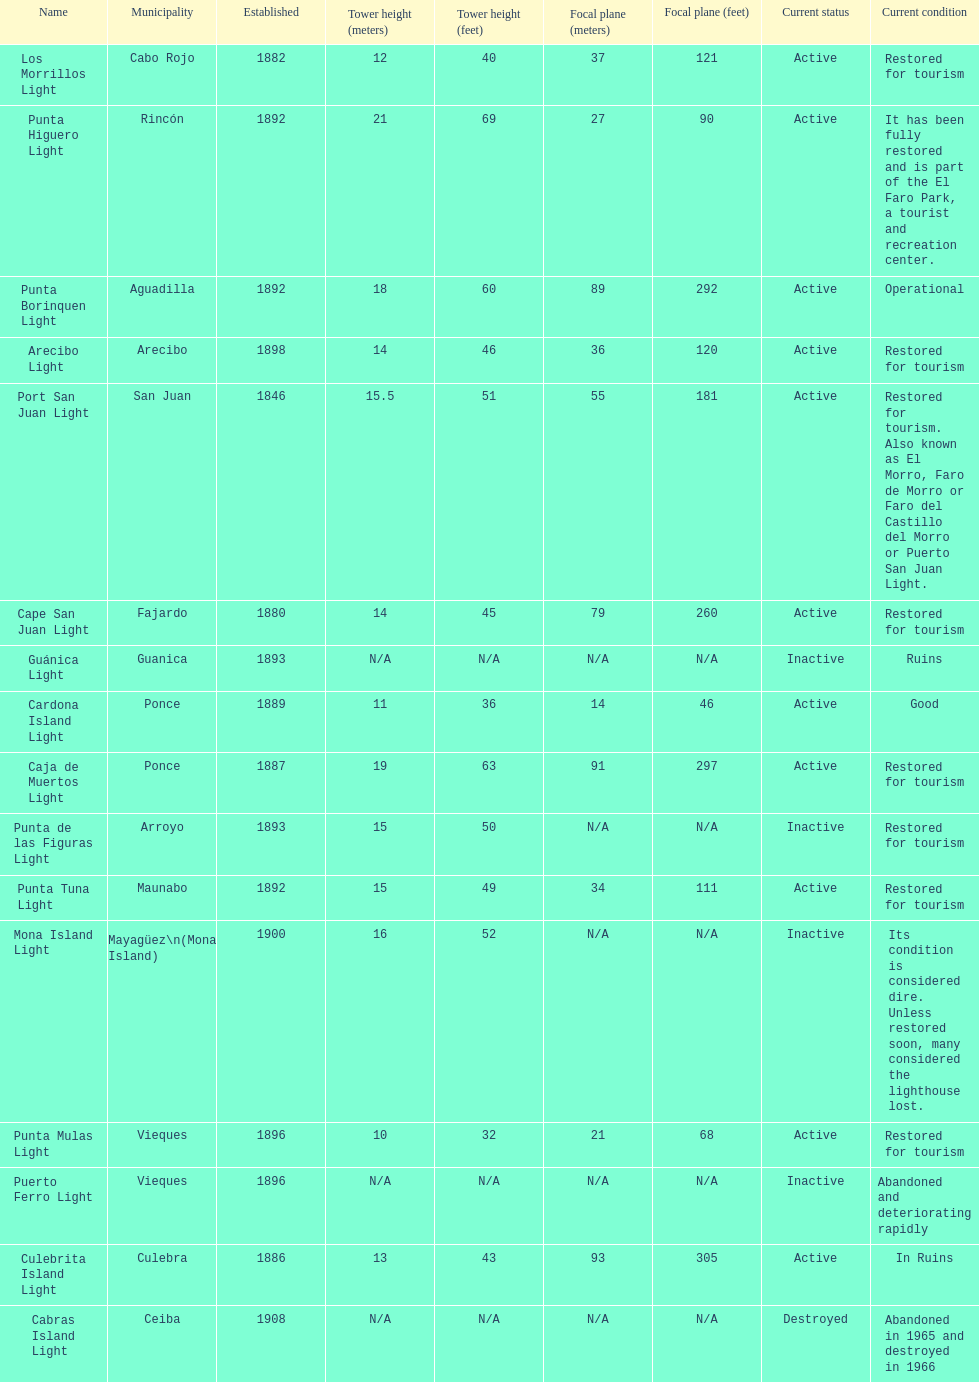Cardona island light and caja de muertos light are both located in what municipality? Ponce. 